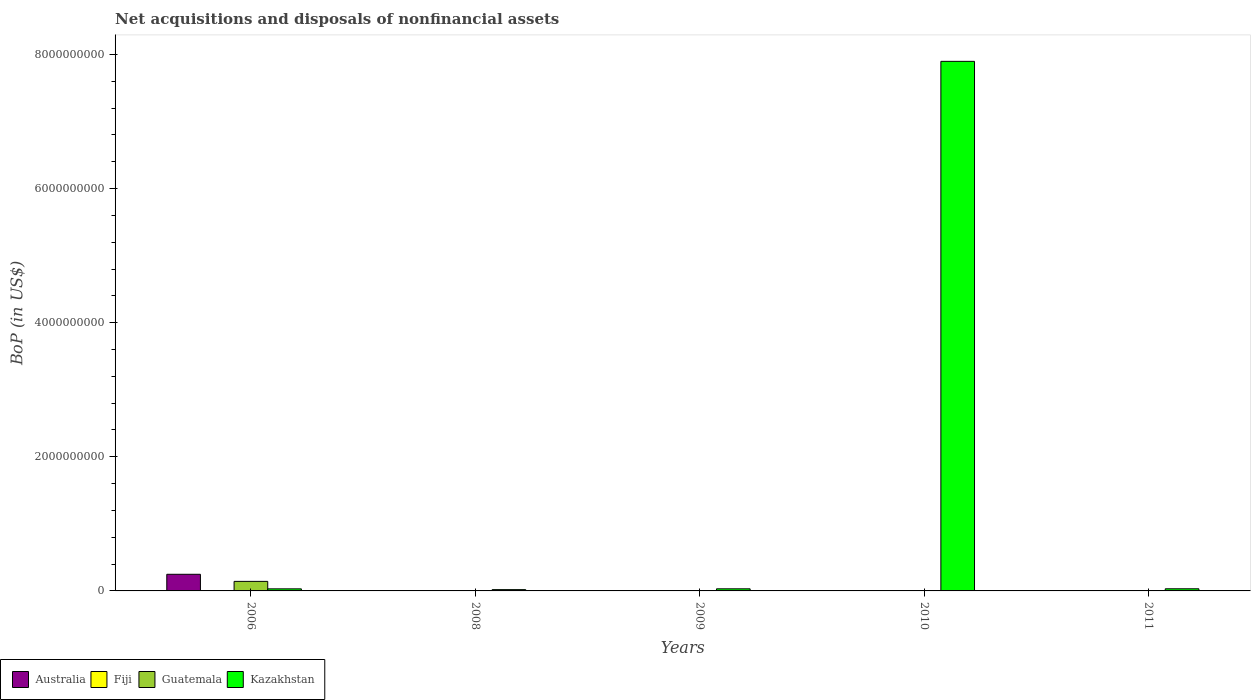How many groups of bars are there?
Ensure brevity in your answer.  5. Are the number of bars per tick equal to the number of legend labels?
Offer a terse response. No. Are the number of bars on each tick of the X-axis equal?
Make the answer very short. No. How many bars are there on the 3rd tick from the left?
Your answer should be compact. 3. Across all years, what is the maximum Balance of Payments in Australia?
Your response must be concise. 2.48e+08. In which year was the Balance of Payments in Guatemala maximum?
Provide a short and direct response. 2006. What is the total Balance of Payments in Kazakhstan in the graph?
Offer a very short reply. 8.01e+09. What is the difference between the Balance of Payments in Kazakhstan in 2008 and that in 2010?
Make the answer very short. -7.88e+09. What is the difference between the Balance of Payments in Australia in 2008 and the Balance of Payments in Guatemala in 2010?
Ensure brevity in your answer.  -2.53e+06. What is the average Balance of Payments in Fiji per year?
Provide a short and direct response. 3.68e+06. In the year 2009, what is the difference between the Balance of Payments in Fiji and Balance of Payments in Kazakhstan?
Your answer should be very brief. -2.90e+07. What is the ratio of the Balance of Payments in Guatemala in 2006 to that in 2011?
Provide a short and direct response. 54.06. What is the difference between the highest and the second highest Balance of Payments in Guatemala?
Ensure brevity in your answer.  1.40e+08. What is the difference between the highest and the lowest Balance of Payments in Kazakhstan?
Ensure brevity in your answer.  7.88e+09. Is it the case that in every year, the sum of the Balance of Payments in Australia and Balance of Payments in Kazakhstan is greater than the Balance of Payments in Fiji?
Provide a short and direct response. Yes. Are all the bars in the graph horizontal?
Make the answer very short. No. How many years are there in the graph?
Your answer should be compact. 5. Where does the legend appear in the graph?
Provide a short and direct response. Bottom left. How many legend labels are there?
Ensure brevity in your answer.  4. How are the legend labels stacked?
Provide a short and direct response. Horizontal. What is the title of the graph?
Your response must be concise. Net acquisitions and disposals of nonfinancial assets. What is the label or title of the Y-axis?
Ensure brevity in your answer.  BoP (in US$). What is the BoP (in US$) in Australia in 2006?
Keep it short and to the point. 2.48e+08. What is the BoP (in US$) in Fiji in 2006?
Your answer should be very brief. 2.02e+06. What is the BoP (in US$) in Guatemala in 2006?
Make the answer very short. 1.42e+08. What is the BoP (in US$) of Kazakhstan in 2006?
Keep it short and to the point. 3.08e+07. What is the BoP (in US$) of Australia in 2008?
Provide a short and direct response. 0. What is the BoP (in US$) of Fiji in 2008?
Your answer should be very brief. 5.19e+06. What is the BoP (in US$) of Guatemala in 2008?
Make the answer very short. 1.08e+06. What is the BoP (in US$) of Kazakhstan in 2008?
Your answer should be compact. 1.93e+07. What is the BoP (in US$) in Fiji in 2009?
Your answer should be very brief. 2.36e+06. What is the BoP (in US$) of Guatemala in 2009?
Your response must be concise. 1.01e+06. What is the BoP (in US$) of Kazakhstan in 2009?
Give a very brief answer. 3.14e+07. What is the BoP (in US$) of Fiji in 2010?
Your answer should be very brief. 2.92e+06. What is the BoP (in US$) in Guatemala in 2010?
Your answer should be very brief. 2.53e+06. What is the BoP (in US$) of Kazakhstan in 2010?
Make the answer very short. 7.90e+09. What is the BoP (in US$) of Australia in 2011?
Your answer should be very brief. 0. What is the BoP (in US$) of Fiji in 2011?
Your answer should be very brief. 5.91e+06. What is the BoP (in US$) in Guatemala in 2011?
Your answer should be very brief. 2.63e+06. What is the BoP (in US$) in Kazakhstan in 2011?
Make the answer very short. 3.18e+07. Across all years, what is the maximum BoP (in US$) of Australia?
Provide a short and direct response. 2.48e+08. Across all years, what is the maximum BoP (in US$) of Fiji?
Your answer should be very brief. 5.91e+06. Across all years, what is the maximum BoP (in US$) in Guatemala?
Offer a very short reply. 1.42e+08. Across all years, what is the maximum BoP (in US$) of Kazakhstan?
Your response must be concise. 7.90e+09. Across all years, what is the minimum BoP (in US$) in Fiji?
Provide a short and direct response. 2.02e+06. Across all years, what is the minimum BoP (in US$) of Guatemala?
Your response must be concise. 1.01e+06. Across all years, what is the minimum BoP (in US$) in Kazakhstan?
Offer a terse response. 1.93e+07. What is the total BoP (in US$) of Australia in the graph?
Your answer should be very brief. 2.48e+08. What is the total BoP (in US$) in Fiji in the graph?
Ensure brevity in your answer.  1.84e+07. What is the total BoP (in US$) of Guatemala in the graph?
Make the answer very short. 1.49e+08. What is the total BoP (in US$) of Kazakhstan in the graph?
Your answer should be compact. 8.01e+09. What is the difference between the BoP (in US$) of Fiji in 2006 and that in 2008?
Your answer should be very brief. -3.17e+06. What is the difference between the BoP (in US$) in Guatemala in 2006 and that in 2008?
Ensure brevity in your answer.  1.41e+08. What is the difference between the BoP (in US$) of Kazakhstan in 2006 and that in 2008?
Offer a terse response. 1.15e+07. What is the difference between the BoP (in US$) of Fiji in 2006 and that in 2009?
Offer a very short reply. -3.32e+05. What is the difference between the BoP (in US$) of Guatemala in 2006 and that in 2009?
Give a very brief answer. 1.41e+08. What is the difference between the BoP (in US$) in Kazakhstan in 2006 and that in 2009?
Provide a succinct answer. -6.16e+05. What is the difference between the BoP (in US$) of Fiji in 2006 and that in 2010?
Ensure brevity in your answer.  -8.97e+05. What is the difference between the BoP (in US$) of Guatemala in 2006 and that in 2010?
Your answer should be very brief. 1.40e+08. What is the difference between the BoP (in US$) of Kazakhstan in 2006 and that in 2010?
Give a very brief answer. -7.87e+09. What is the difference between the BoP (in US$) in Fiji in 2006 and that in 2011?
Make the answer very short. -3.89e+06. What is the difference between the BoP (in US$) of Guatemala in 2006 and that in 2011?
Offer a very short reply. 1.40e+08. What is the difference between the BoP (in US$) in Kazakhstan in 2006 and that in 2011?
Provide a succinct answer. -1.01e+06. What is the difference between the BoP (in US$) in Fiji in 2008 and that in 2009?
Your answer should be very brief. 2.84e+06. What is the difference between the BoP (in US$) in Guatemala in 2008 and that in 2009?
Keep it short and to the point. 6.75e+04. What is the difference between the BoP (in US$) in Kazakhstan in 2008 and that in 2009?
Your answer should be very brief. -1.21e+07. What is the difference between the BoP (in US$) in Fiji in 2008 and that in 2010?
Keep it short and to the point. 2.27e+06. What is the difference between the BoP (in US$) of Guatemala in 2008 and that in 2010?
Your answer should be very brief. -1.45e+06. What is the difference between the BoP (in US$) in Kazakhstan in 2008 and that in 2010?
Ensure brevity in your answer.  -7.88e+09. What is the difference between the BoP (in US$) of Fiji in 2008 and that in 2011?
Keep it short and to the point. -7.21e+05. What is the difference between the BoP (in US$) of Guatemala in 2008 and that in 2011?
Ensure brevity in your answer.  -1.55e+06. What is the difference between the BoP (in US$) of Kazakhstan in 2008 and that in 2011?
Offer a terse response. -1.25e+07. What is the difference between the BoP (in US$) in Fiji in 2009 and that in 2010?
Your response must be concise. -5.65e+05. What is the difference between the BoP (in US$) in Guatemala in 2009 and that in 2010?
Ensure brevity in your answer.  -1.52e+06. What is the difference between the BoP (in US$) in Kazakhstan in 2009 and that in 2010?
Your response must be concise. -7.87e+09. What is the difference between the BoP (in US$) of Fiji in 2009 and that in 2011?
Provide a short and direct response. -3.56e+06. What is the difference between the BoP (in US$) of Guatemala in 2009 and that in 2011?
Your answer should be very brief. -1.62e+06. What is the difference between the BoP (in US$) of Kazakhstan in 2009 and that in 2011?
Provide a short and direct response. -3.92e+05. What is the difference between the BoP (in US$) in Fiji in 2010 and that in 2011?
Give a very brief answer. -2.99e+06. What is the difference between the BoP (in US$) of Guatemala in 2010 and that in 2011?
Provide a succinct answer. -9.72e+04. What is the difference between the BoP (in US$) of Kazakhstan in 2010 and that in 2011?
Offer a very short reply. 7.87e+09. What is the difference between the BoP (in US$) in Australia in 2006 and the BoP (in US$) in Fiji in 2008?
Keep it short and to the point. 2.43e+08. What is the difference between the BoP (in US$) in Australia in 2006 and the BoP (in US$) in Guatemala in 2008?
Your response must be concise. 2.47e+08. What is the difference between the BoP (in US$) of Australia in 2006 and the BoP (in US$) of Kazakhstan in 2008?
Give a very brief answer. 2.29e+08. What is the difference between the BoP (in US$) in Fiji in 2006 and the BoP (in US$) in Guatemala in 2008?
Your response must be concise. 9.46e+05. What is the difference between the BoP (in US$) of Fiji in 2006 and the BoP (in US$) of Kazakhstan in 2008?
Keep it short and to the point. -1.73e+07. What is the difference between the BoP (in US$) of Guatemala in 2006 and the BoP (in US$) of Kazakhstan in 2008?
Provide a succinct answer. 1.23e+08. What is the difference between the BoP (in US$) in Australia in 2006 and the BoP (in US$) in Fiji in 2009?
Your answer should be very brief. 2.46e+08. What is the difference between the BoP (in US$) in Australia in 2006 and the BoP (in US$) in Guatemala in 2009?
Your answer should be very brief. 2.47e+08. What is the difference between the BoP (in US$) of Australia in 2006 and the BoP (in US$) of Kazakhstan in 2009?
Ensure brevity in your answer.  2.17e+08. What is the difference between the BoP (in US$) in Fiji in 2006 and the BoP (in US$) in Guatemala in 2009?
Your answer should be very brief. 1.01e+06. What is the difference between the BoP (in US$) in Fiji in 2006 and the BoP (in US$) in Kazakhstan in 2009?
Your response must be concise. -2.94e+07. What is the difference between the BoP (in US$) in Guatemala in 2006 and the BoP (in US$) in Kazakhstan in 2009?
Your response must be concise. 1.11e+08. What is the difference between the BoP (in US$) in Australia in 2006 and the BoP (in US$) in Fiji in 2010?
Offer a terse response. 2.45e+08. What is the difference between the BoP (in US$) in Australia in 2006 and the BoP (in US$) in Guatemala in 2010?
Your response must be concise. 2.45e+08. What is the difference between the BoP (in US$) of Australia in 2006 and the BoP (in US$) of Kazakhstan in 2010?
Your answer should be very brief. -7.65e+09. What is the difference between the BoP (in US$) of Fiji in 2006 and the BoP (in US$) of Guatemala in 2010?
Provide a short and direct response. -5.08e+05. What is the difference between the BoP (in US$) in Fiji in 2006 and the BoP (in US$) in Kazakhstan in 2010?
Offer a very short reply. -7.90e+09. What is the difference between the BoP (in US$) in Guatemala in 2006 and the BoP (in US$) in Kazakhstan in 2010?
Your answer should be very brief. -7.76e+09. What is the difference between the BoP (in US$) of Australia in 2006 and the BoP (in US$) of Fiji in 2011?
Provide a short and direct response. 2.42e+08. What is the difference between the BoP (in US$) in Australia in 2006 and the BoP (in US$) in Guatemala in 2011?
Keep it short and to the point. 2.45e+08. What is the difference between the BoP (in US$) of Australia in 2006 and the BoP (in US$) of Kazakhstan in 2011?
Provide a succinct answer. 2.16e+08. What is the difference between the BoP (in US$) in Fiji in 2006 and the BoP (in US$) in Guatemala in 2011?
Provide a succinct answer. -6.05e+05. What is the difference between the BoP (in US$) in Fiji in 2006 and the BoP (in US$) in Kazakhstan in 2011?
Provide a short and direct response. -2.98e+07. What is the difference between the BoP (in US$) of Guatemala in 2006 and the BoP (in US$) of Kazakhstan in 2011?
Give a very brief answer. 1.10e+08. What is the difference between the BoP (in US$) of Fiji in 2008 and the BoP (in US$) of Guatemala in 2009?
Give a very brief answer. 4.18e+06. What is the difference between the BoP (in US$) in Fiji in 2008 and the BoP (in US$) in Kazakhstan in 2009?
Keep it short and to the point. -2.62e+07. What is the difference between the BoP (in US$) in Guatemala in 2008 and the BoP (in US$) in Kazakhstan in 2009?
Make the answer very short. -3.03e+07. What is the difference between the BoP (in US$) of Fiji in 2008 and the BoP (in US$) of Guatemala in 2010?
Your response must be concise. 2.66e+06. What is the difference between the BoP (in US$) of Fiji in 2008 and the BoP (in US$) of Kazakhstan in 2010?
Your response must be concise. -7.89e+09. What is the difference between the BoP (in US$) in Guatemala in 2008 and the BoP (in US$) in Kazakhstan in 2010?
Give a very brief answer. -7.90e+09. What is the difference between the BoP (in US$) in Fiji in 2008 and the BoP (in US$) in Guatemala in 2011?
Keep it short and to the point. 2.56e+06. What is the difference between the BoP (in US$) in Fiji in 2008 and the BoP (in US$) in Kazakhstan in 2011?
Make the answer very short. -2.66e+07. What is the difference between the BoP (in US$) of Guatemala in 2008 and the BoP (in US$) of Kazakhstan in 2011?
Provide a succinct answer. -3.07e+07. What is the difference between the BoP (in US$) of Fiji in 2009 and the BoP (in US$) of Guatemala in 2010?
Give a very brief answer. -1.77e+05. What is the difference between the BoP (in US$) of Fiji in 2009 and the BoP (in US$) of Kazakhstan in 2010?
Your answer should be compact. -7.90e+09. What is the difference between the BoP (in US$) in Guatemala in 2009 and the BoP (in US$) in Kazakhstan in 2010?
Provide a succinct answer. -7.90e+09. What is the difference between the BoP (in US$) of Fiji in 2009 and the BoP (in US$) of Guatemala in 2011?
Ensure brevity in your answer.  -2.74e+05. What is the difference between the BoP (in US$) of Fiji in 2009 and the BoP (in US$) of Kazakhstan in 2011?
Give a very brief answer. -2.94e+07. What is the difference between the BoP (in US$) in Guatemala in 2009 and the BoP (in US$) in Kazakhstan in 2011?
Your answer should be compact. -3.08e+07. What is the difference between the BoP (in US$) of Fiji in 2010 and the BoP (in US$) of Guatemala in 2011?
Give a very brief answer. 2.91e+05. What is the difference between the BoP (in US$) in Fiji in 2010 and the BoP (in US$) in Kazakhstan in 2011?
Give a very brief answer. -2.89e+07. What is the difference between the BoP (in US$) in Guatemala in 2010 and the BoP (in US$) in Kazakhstan in 2011?
Your answer should be very brief. -2.93e+07. What is the average BoP (in US$) of Australia per year?
Offer a terse response. 4.96e+07. What is the average BoP (in US$) of Fiji per year?
Offer a very short reply. 3.68e+06. What is the average BoP (in US$) of Guatemala per year?
Provide a succinct answer. 2.99e+07. What is the average BoP (in US$) of Kazakhstan per year?
Offer a very short reply. 1.60e+09. In the year 2006, what is the difference between the BoP (in US$) of Australia and BoP (in US$) of Fiji?
Your response must be concise. 2.46e+08. In the year 2006, what is the difference between the BoP (in US$) of Australia and BoP (in US$) of Guatemala?
Give a very brief answer. 1.06e+08. In the year 2006, what is the difference between the BoP (in US$) in Australia and BoP (in US$) in Kazakhstan?
Provide a short and direct response. 2.17e+08. In the year 2006, what is the difference between the BoP (in US$) of Fiji and BoP (in US$) of Guatemala?
Offer a terse response. -1.40e+08. In the year 2006, what is the difference between the BoP (in US$) of Fiji and BoP (in US$) of Kazakhstan?
Offer a very short reply. -2.88e+07. In the year 2006, what is the difference between the BoP (in US$) in Guatemala and BoP (in US$) in Kazakhstan?
Your answer should be very brief. 1.11e+08. In the year 2008, what is the difference between the BoP (in US$) in Fiji and BoP (in US$) in Guatemala?
Your answer should be very brief. 4.11e+06. In the year 2008, what is the difference between the BoP (in US$) in Fiji and BoP (in US$) in Kazakhstan?
Keep it short and to the point. -1.41e+07. In the year 2008, what is the difference between the BoP (in US$) of Guatemala and BoP (in US$) of Kazakhstan?
Your response must be concise. -1.82e+07. In the year 2009, what is the difference between the BoP (in US$) in Fiji and BoP (in US$) in Guatemala?
Provide a succinct answer. 1.34e+06. In the year 2009, what is the difference between the BoP (in US$) in Fiji and BoP (in US$) in Kazakhstan?
Ensure brevity in your answer.  -2.90e+07. In the year 2009, what is the difference between the BoP (in US$) of Guatemala and BoP (in US$) of Kazakhstan?
Make the answer very short. -3.04e+07. In the year 2010, what is the difference between the BoP (in US$) of Fiji and BoP (in US$) of Guatemala?
Keep it short and to the point. 3.89e+05. In the year 2010, what is the difference between the BoP (in US$) of Fiji and BoP (in US$) of Kazakhstan?
Keep it short and to the point. -7.90e+09. In the year 2010, what is the difference between the BoP (in US$) in Guatemala and BoP (in US$) in Kazakhstan?
Offer a terse response. -7.90e+09. In the year 2011, what is the difference between the BoP (in US$) of Fiji and BoP (in US$) of Guatemala?
Ensure brevity in your answer.  3.28e+06. In the year 2011, what is the difference between the BoP (in US$) in Fiji and BoP (in US$) in Kazakhstan?
Keep it short and to the point. -2.59e+07. In the year 2011, what is the difference between the BoP (in US$) of Guatemala and BoP (in US$) of Kazakhstan?
Provide a short and direct response. -2.92e+07. What is the ratio of the BoP (in US$) of Fiji in 2006 to that in 2008?
Make the answer very short. 0.39. What is the ratio of the BoP (in US$) in Guatemala in 2006 to that in 2008?
Ensure brevity in your answer.  131.74. What is the ratio of the BoP (in US$) in Kazakhstan in 2006 to that in 2008?
Your response must be concise. 1.59. What is the ratio of the BoP (in US$) in Fiji in 2006 to that in 2009?
Ensure brevity in your answer.  0.86. What is the ratio of the BoP (in US$) in Guatemala in 2006 to that in 2009?
Provide a succinct answer. 140.53. What is the ratio of the BoP (in US$) in Kazakhstan in 2006 to that in 2009?
Make the answer very short. 0.98. What is the ratio of the BoP (in US$) in Fiji in 2006 to that in 2010?
Your answer should be very brief. 0.69. What is the ratio of the BoP (in US$) of Guatemala in 2006 to that in 2010?
Provide a succinct answer. 56.14. What is the ratio of the BoP (in US$) of Kazakhstan in 2006 to that in 2010?
Give a very brief answer. 0. What is the ratio of the BoP (in US$) in Fiji in 2006 to that in 2011?
Your response must be concise. 0.34. What is the ratio of the BoP (in US$) in Guatemala in 2006 to that in 2011?
Give a very brief answer. 54.06. What is the ratio of the BoP (in US$) of Kazakhstan in 2006 to that in 2011?
Keep it short and to the point. 0.97. What is the ratio of the BoP (in US$) of Fiji in 2008 to that in 2009?
Make the answer very short. 2.2. What is the ratio of the BoP (in US$) in Guatemala in 2008 to that in 2009?
Offer a very short reply. 1.07. What is the ratio of the BoP (in US$) in Kazakhstan in 2008 to that in 2009?
Make the answer very short. 0.61. What is the ratio of the BoP (in US$) in Fiji in 2008 to that in 2010?
Provide a succinct answer. 1.78. What is the ratio of the BoP (in US$) of Guatemala in 2008 to that in 2010?
Give a very brief answer. 0.43. What is the ratio of the BoP (in US$) in Kazakhstan in 2008 to that in 2010?
Offer a terse response. 0. What is the ratio of the BoP (in US$) in Fiji in 2008 to that in 2011?
Keep it short and to the point. 0.88. What is the ratio of the BoP (in US$) in Guatemala in 2008 to that in 2011?
Give a very brief answer. 0.41. What is the ratio of the BoP (in US$) in Kazakhstan in 2008 to that in 2011?
Your answer should be very brief. 0.61. What is the ratio of the BoP (in US$) of Fiji in 2009 to that in 2010?
Your answer should be compact. 0.81. What is the ratio of the BoP (in US$) of Guatemala in 2009 to that in 2010?
Your answer should be very brief. 0.4. What is the ratio of the BoP (in US$) in Kazakhstan in 2009 to that in 2010?
Make the answer very short. 0. What is the ratio of the BoP (in US$) of Fiji in 2009 to that in 2011?
Your answer should be compact. 0.4. What is the ratio of the BoP (in US$) in Guatemala in 2009 to that in 2011?
Offer a very short reply. 0.38. What is the ratio of the BoP (in US$) of Fiji in 2010 to that in 2011?
Keep it short and to the point. 0.49. What is the ratio of the BoP (in US$) of Kazakhstan in 2010 to that in 2011?
Your answer should be compact. 248.41. What is the difference between the highest and the second highest BoP (in US$) in Fiji?
Offer a terse response. 7.21e+05. What is the difference between the highest and the second highest BoP (in US$) of Guatemala?
Make the answer very short. 1.40e+08. What is the difference between the highest and the second highest BoP (in US$) of Kazakhstan?
Give a very brief answer. 7.87e+09. What is the difference between the highest and the lowest BoP (in US$) in Australia?
Offer a very short reply. 2.48e+08. What is the difference between the highest and the lowest BoP (in US$) in Fiji?
Make the answer very short. 3.89e+06. What is the difference between the highest and the lowest BoP (in US$) in Guatemala?
Provide a succinct answer. 1.41e+08. What is the difference between the highest and the lowest BoP (in US$) in Kazakhstan?
Offer a very short reply. 7.88e+09. 